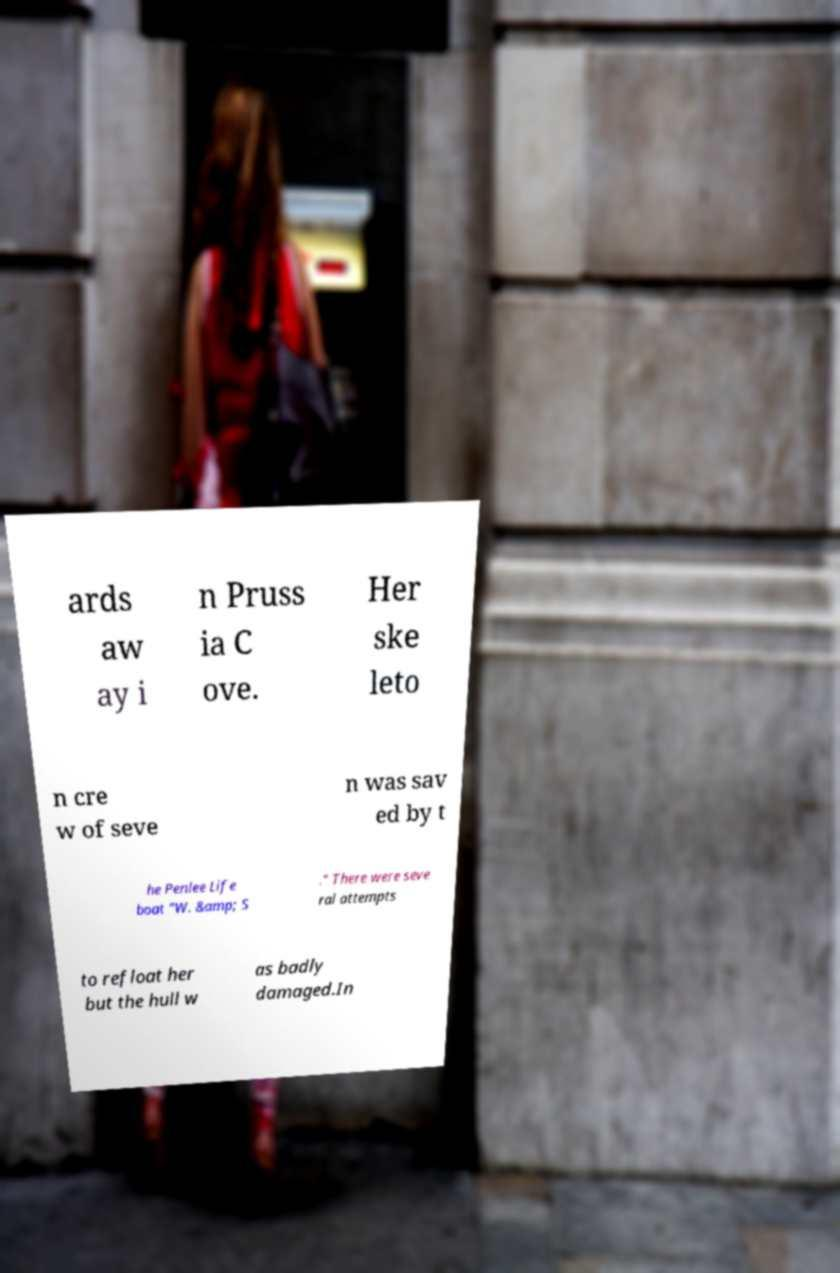What messages or text are displayed in this image? I need them in a readable, typed format. ards aw ay i n Pruss ia C ove. Her ske leto n cre w of seve n was sav ed by t he Penlee Life boat "W. &amp; S ." There were seve ral attempts to refloat her but the hull w as badly damaged.In 